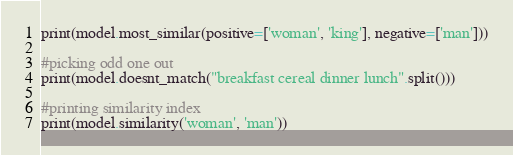Convert code to text. <code><loc_0><loc_0><loc_500><loc_500><_Python_>print(model.most_similar(positive=['woman', 'king'], negative=['man']))

#picking odd one out
print(model.doesnt_match("breakfast cereal dinner lunch".split()))

#printing similarity index
print(model.similarity('woman', 'man'))
</code> 